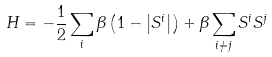<formula> <loc_0><loc_0><loc_500><loc_500>H = - \frac { 1 } { 2 } \sum _ { i } \beta \left ( 1 - \left | S ^ { i } \right | \right ) + \beta \sum _ { i \neq j } S ^ { i } S ^ { j }</formula> 